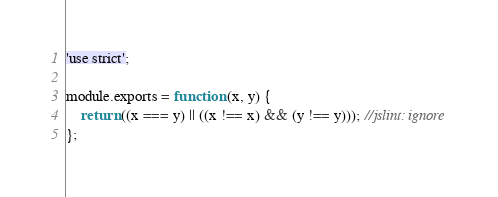<code> <loc_0><loc_0><loc_500><loc_500><_JavaScript_>'use strict';

module.exports = function (x, y) {
	return ((x === y) || ((x !== x) && (y !== y))); //jslint: ignore
};
</code> 